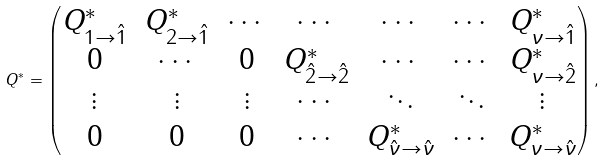<formula> <loc_0><loc_0><loc_500><loc_500>Q ^ { * } = \begin{pmatrix} Q ^ { * } _ { 1 \to \hat { 1 } } & Q ^ { * } _ { 2 \to \hat { 1 } } & \cdots & \cdots & \cdots & \cdots & Q ^ { * } _ { { \nu } \to \hat { 1 } } \\ 0 & \cdots & 0 & Q ^ { * } _ { \hat { 2 } \to \hat { 2 } } & \cdots & \cdots & Q ^ { * } _ { { \nu } \to \hat { 2 } } \\ \vdots & \vdots & \vdots & \cdots & \ddots & \ddots & \vdots \\ 0 & 0 & 0 & \cdots & Q ^ { * } _ { \hat { \nu } \to \hat { \nu } } & \cdots & Q ^ { * } _ { { \nu } \to \hat { \nu } } \end{pmatrix} ,</formula> 